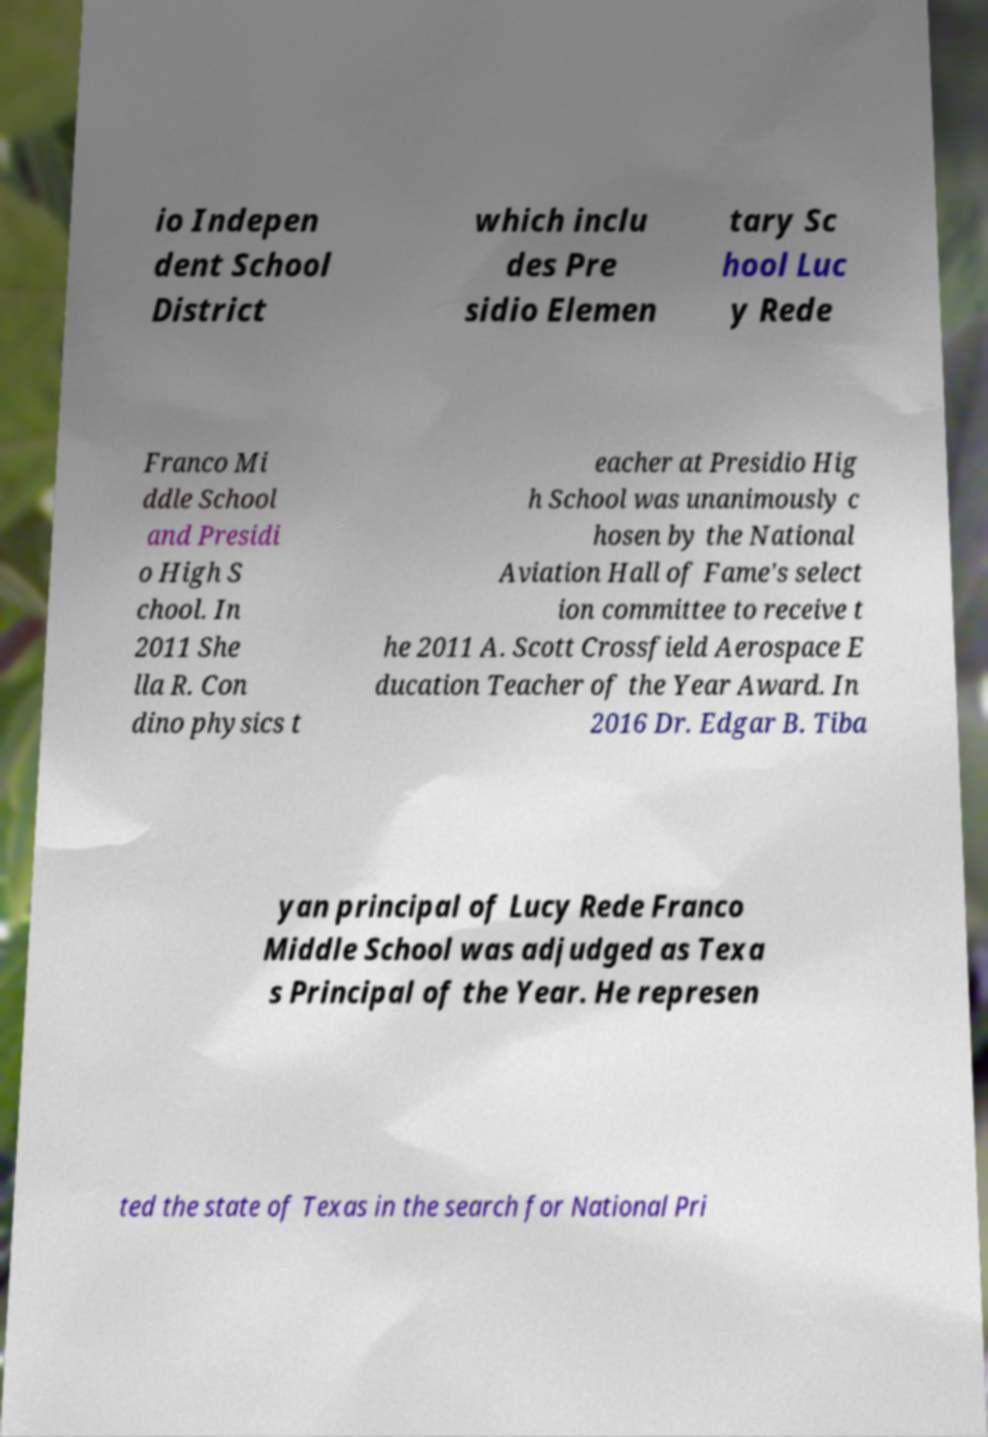Please read and relay the text visible in this image. What does it say? io Indepen dent School District which inclu des Pre sidio Elemen tary Sc hool Luc y Rede Franco Mi ddle School and Presidi o High S chool. In 2011 She lla R. Con dino physics t eacher at Presidio Hig h School was unanimously c hosen by the National Aviation Hall of Fame's select ion committee to receive t he 2011 A. Scott Crossfield Aerospace E ducation Teacher of the Year Award. In 2016 Dr. Edgar B. Tiba yan principal of Lucy Rede Franco Middle School was adjudged as Texa s Principal of the Year. He represen ted the state of Texas in the search for National Pri 